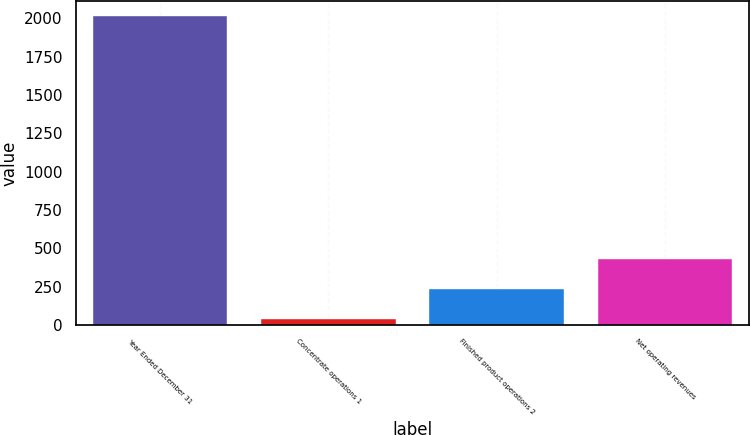Convert chart. <chart><loc_0><loc_0><loc_500><loc_500><bar_chart><fcel>Year Ended December 31<fcel>Concentrate operations 1<fcel>Finished product operations 2<fcel>Net operating revenues<nl><fcel>2013<fcel>38<fcel>235.5<fcel>433<nl></chart> 